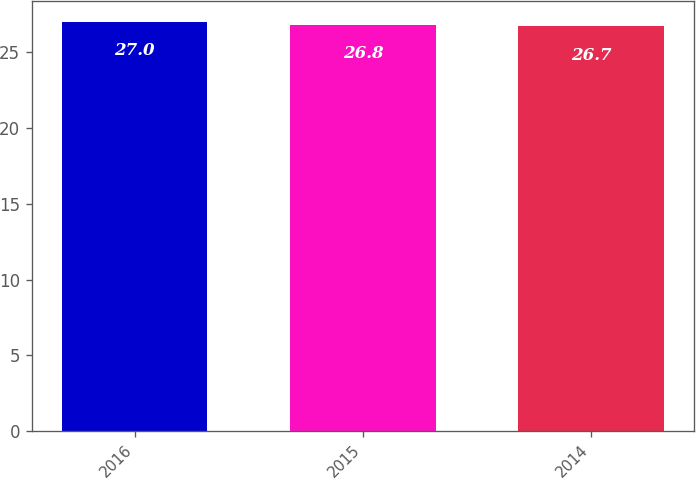Convert chart. <chart><loc_0><loc_0><loc_500><loc_500><bar_chart><fcel>2016<fcel>2015<fcel>2014<nl><fcel>27<fcel>26.8<fcel>26.7<nl></chart> 